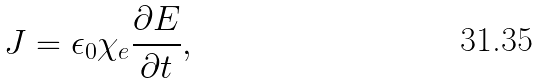Convert formula to latex. <formula><loc_0><loc_0><loc_500><loc_500>J = \epsilon _ { 0 } \chi _ { e } \frac { \partial E } { \partial t } ,</formula> 